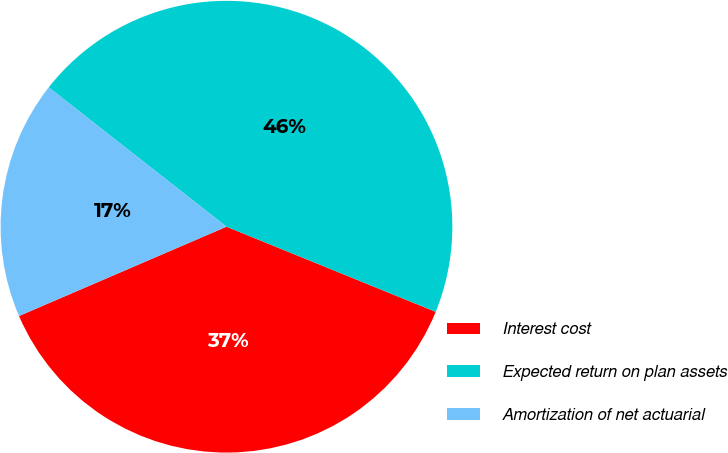Convert chart. <chart><loc_0><loc_0><loc_500><loc_500><pie_chart><fcel>Interest cost<fcel>Expected return on plan assets<fcel>Amortization of net actuarial<nl><fcel>37.38%<fcel>45.57%<fcel>17.05%<nl></chart> 